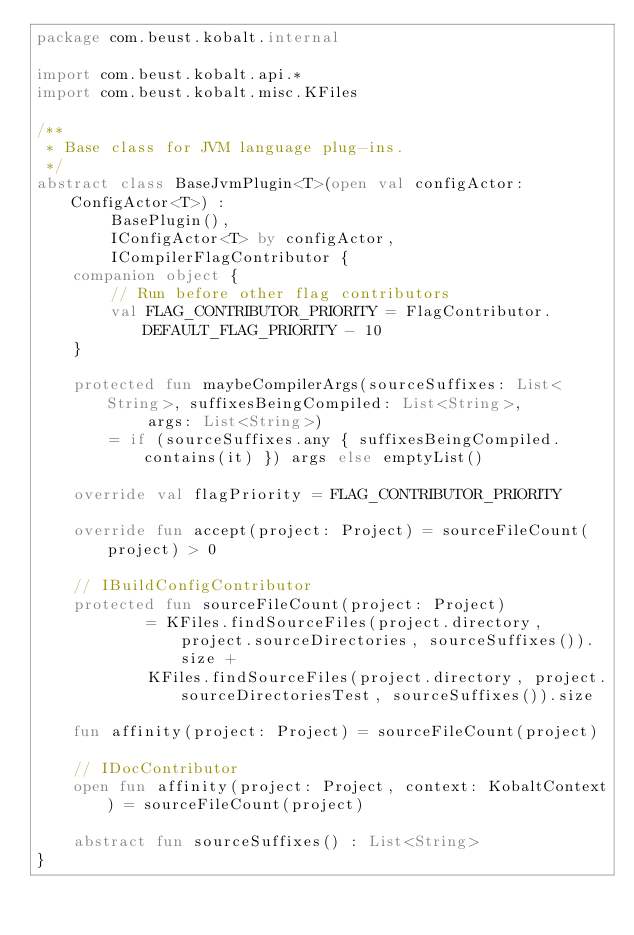Convert code to text. <code><loc_0><loc_0><loc_500><loc_500><_Kotlin_>package com.beust.kobalt.internal

import com.beust.kobalt.api.*
import com.beust.kobalt.misc.KFiles

/**
 * Base class for JVM language plug-ins.
 */
abstract class BaseJvmPlugin<T>(open val configActor: ConfigActor<T>) :
        BasePlugin(),
        IConfigActor<T> by configActor,
        ICompilerFlagContributor {
    companion object {
        // Run before other flag contributors
        val FLAG_CONTRIBUTOR_PRIORITY = FlagContributor.DEFAULT_FLAG_PRIORITY - 10
    }

    protected fun maybeCompilerArgs(sourceSuffixes: List<String>, suffixesBeingCompiled: List<String>,
            args: List<String>)
        = if (sourceSuffixes.any { suffixesBeingCompiled.contains(it) }) args else emptyList()

    override val flagPriority = FLAG_CONTRIBUTOR_PRIORITY

    override fun accept(project: Project) = sourceFileCount(project) > 0

    // IBuildConfigContributor
    protected fun sourceFileCount(project: Project)
            = KFiles.findSourceFiles(project.directory, project.sourceDirectories, sourceSuffixes()).size +
            KFiles.findSourceFiles(project.directory, project.sourceDirectoriesTest, sourceSuffixes()).size

    fun affinity(project: Project) = sourceFileCount(project)

    // IDocContributor
    open fun affinity(project: Project, context: KobaltContext) = sourceFileCount(project)

    abstract fun sourceSuffixes() : List<String>
}</code> 